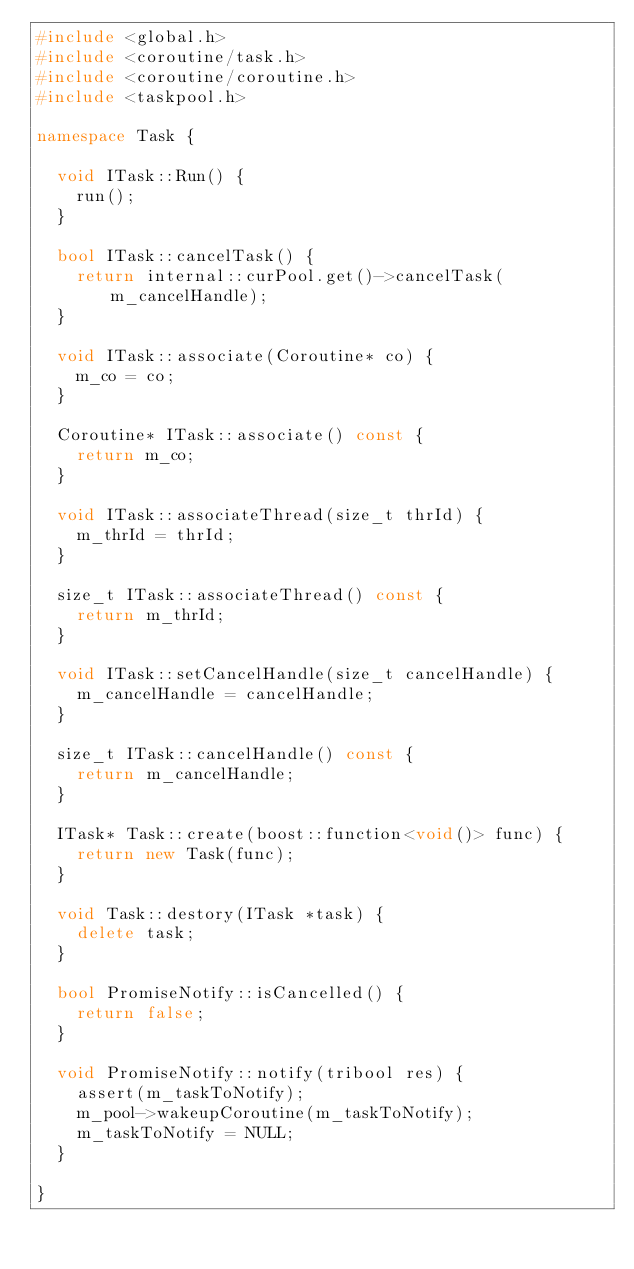<code> <loc_0><loc_0><loc_500><loc_500><_C++_>#include <global.h>
#include <coroutine/task.h>
#include <coroutine/coroutine.h>
#include <taskpool.h>

namespace Task {

	void ITask::Run() {
		run();
	}

	bool ITask::cancelTask() {
		return internal::curPool.get()->cancelTask(m_cancelHandle);
	}

	void ITask::associate(Coroutine* co) {
		m_co = co;
	}

	Coroutine* ITask::associate() const {
		return m_co;
	}

	void ITask::associateThread(size_t thrId) {
		m_thrId = thrId;
	}

	size_t ITask::associateThread() const {
		return m_thrId;
	}

	void ITask::setCancelHandle(size_t cancelHandle) {
		m_cancelHandle = cancelHandle;
	}

	size_t ITask::cancelHandle() const {
		return m_cancelHandle;
	}

	ITask* Task::create(boost::function<void()> func) {
		return new Task(func);
	}

	void Task::destory(ITask *task) {
		delete task;
	}

	bool PromiseNotify::isCancelled() {
		return false;
	}

	void PromiseNotify::notify(tribool res) {
		assert(m_taskToNotify);
		m_pool->wakeupCoroutine(m_taskToNotify);
		m_taskToNotify = NULL;
	}

}
</code> 